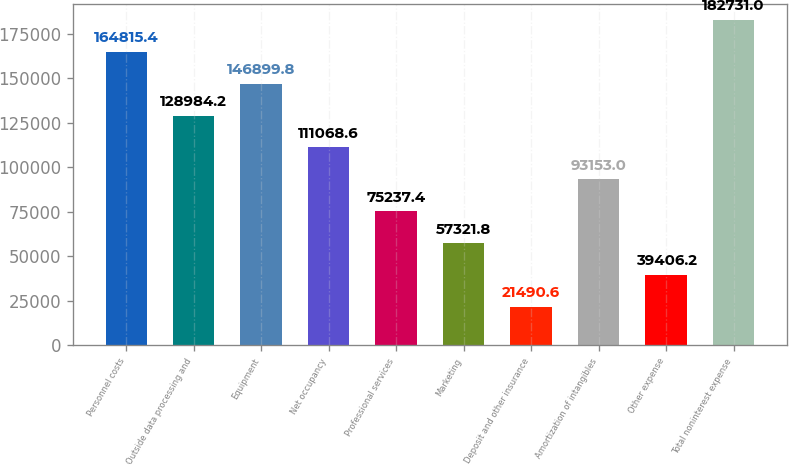Convert chart to OTSL. <chart><loc_0><loc_0><loc_500><loc_500><bar_chart><fcel>Personnel costs<fcel>Outside data processing and<fcel>Equipment<fcel>Net occupancy<fcel>Professional services<fcel>Marketing<fcel>Deposit and other insurance<fcel>Amortization of intangibles<fcel>Other expense<fcel>Total noninterest expense<nl><fcel>164815<fcel>128984<fcel>146900<fcel>111069<fcel>75237.4<fcel>57321.8<fcel>21490.6<fcel>93153<fcel>39406.2<fcel>182731<nl></chart> 